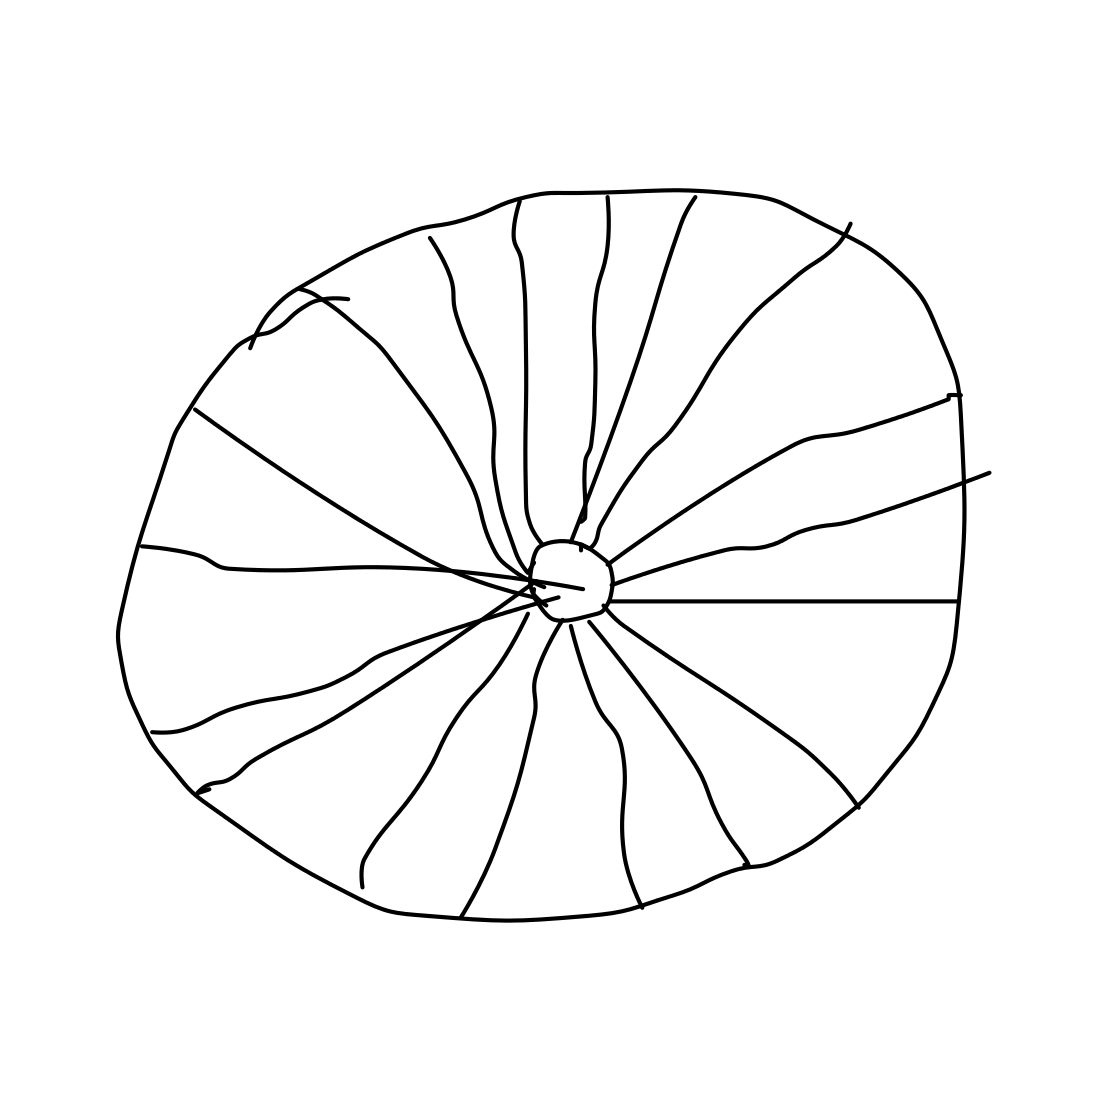Can you describe the pattern used in the wheel design? The wheel features a radial pattern with lines extending from the center to the outer edge, creating sections that resemble the spokes of a traditional wheel. This design is simplistic yet evocative of mechanical and functional aspects typical of wheels used in various machinery. 